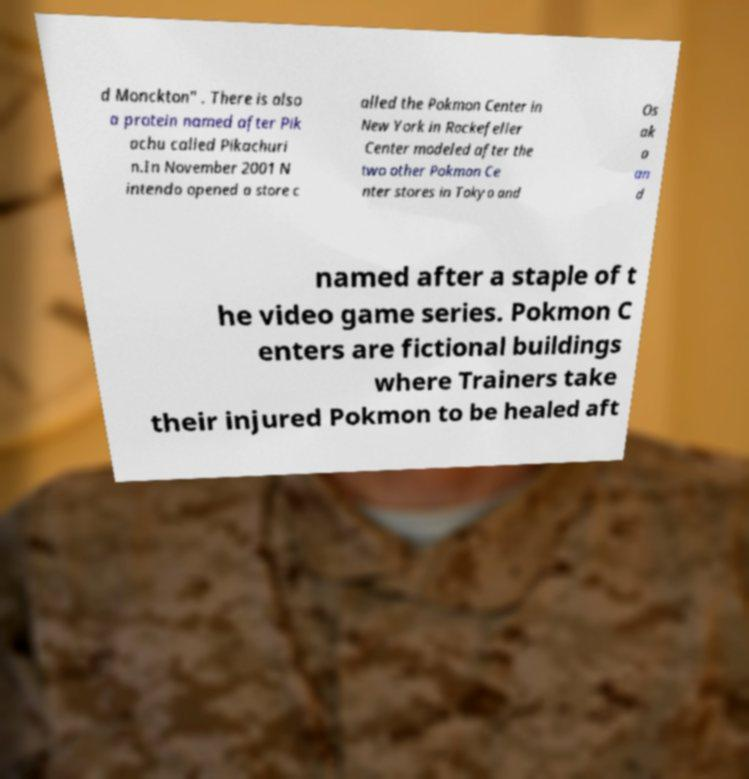There's text embedded in this image that I need extracted. Can you transcribe it verbatim? d Monckton" . There is also a protein named after Pik achu called Pikachuri n.In November 2001 N intendo opened a store c alled the Pokmon Center in New York in Rockefeller Center modeled after the two other Pokmon Ce nter stores in Tokyo and Os ak a an d named after a staple of t he video game series. Pokmon C enters are fictional buildings where Trainers take their injured Pokmon to be healed aft 